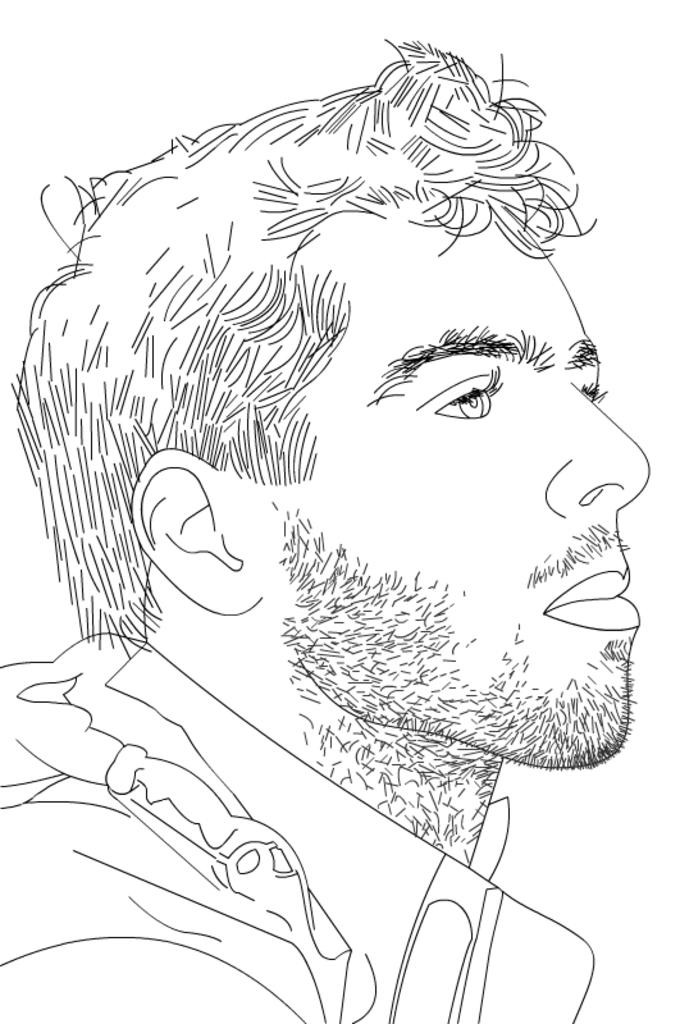What is depicted in the image? There is a drawing of a person in the image. Where is the sugar factory located in the image? There is no sugar factory present in the image; it only features a drawing of a person. Is the queen present in the image? There is no queen present in the image; it only features a drawing of a person. 